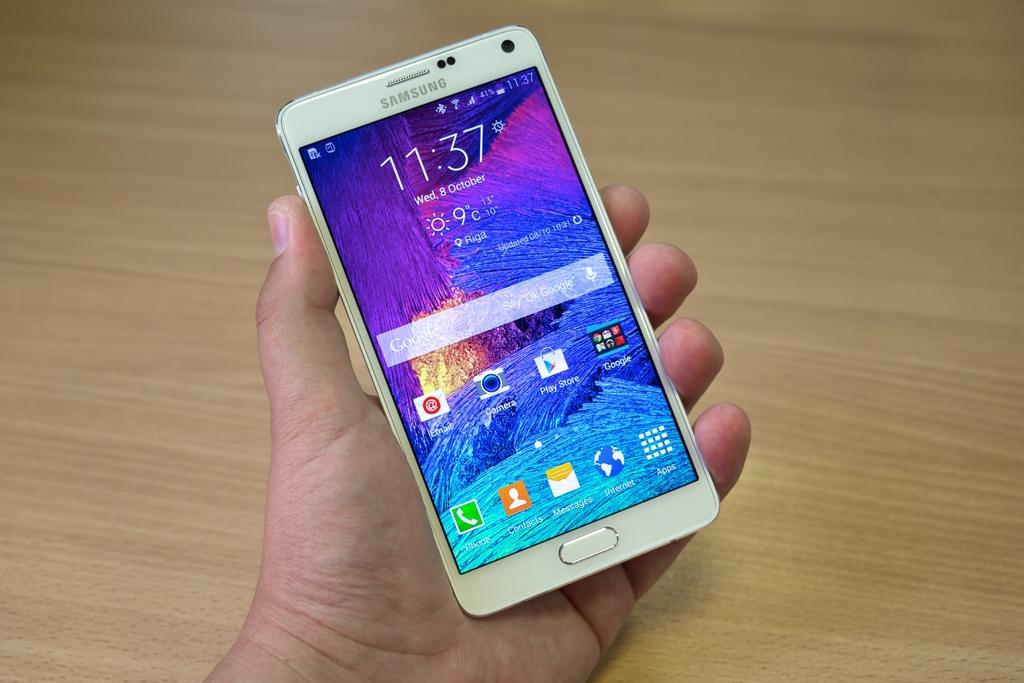What time is it on the phone?
Give a very brief answer. 11:37. What brand phone is this?
Provide a succinct answer. Samsung. 